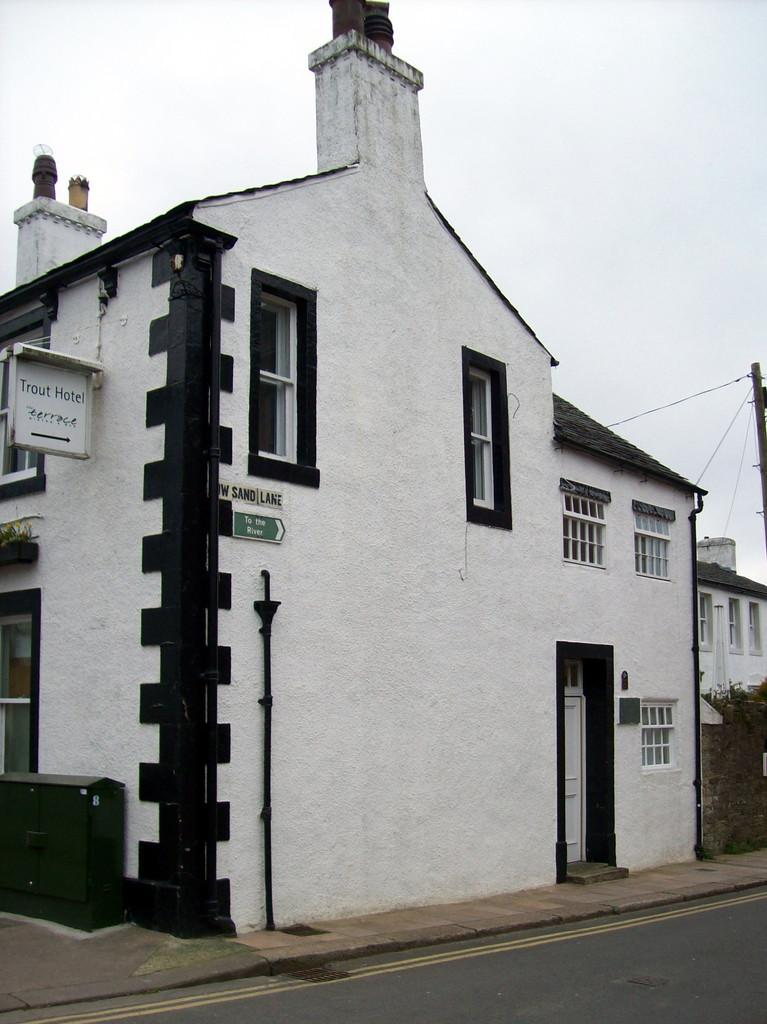What type of structures can be seen in the image? There are buildings in the image. What architectural features are visible on the buildings? Windows and a door are visible in the image. What type of vegetation is present in the image? There is a plant in the image. What is visible in the background of the image? The sky is visible in the image. What type of light can be seen in the image? There is no specific light source mentioned in the image; it only shows buildings, windows, a door, a plant, and the sky. 